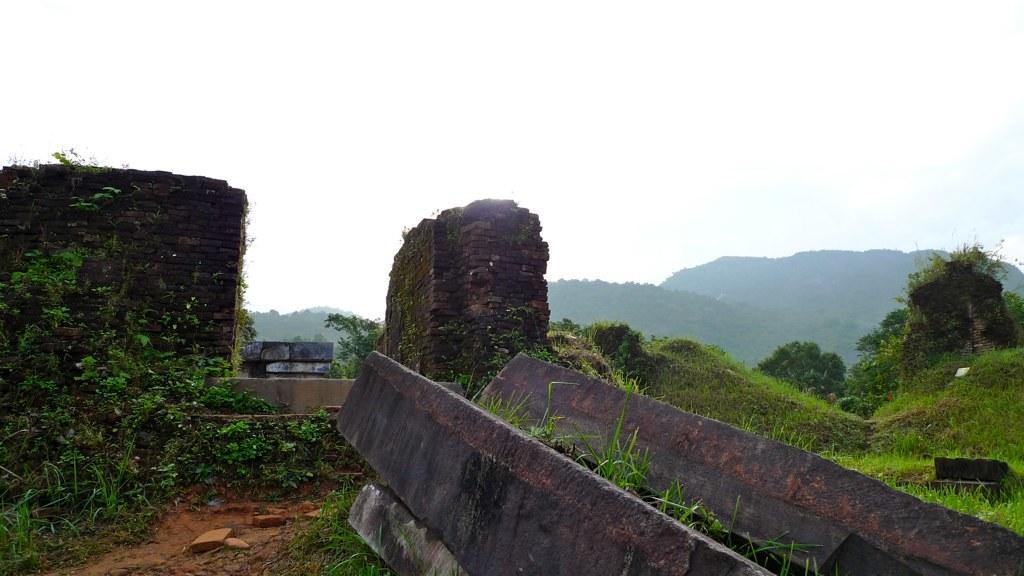In one or two sentences, can you explain what this image depicts? In this image we can see the rocks and grass on the surface, in the background of the image there are mountains. 